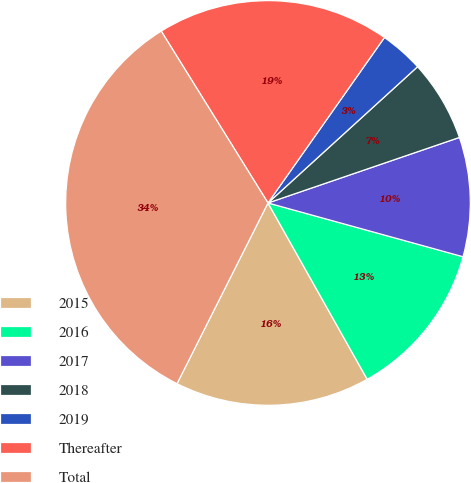<chart> <loc_0><loc_0><loc_500><loc_500><pie_chart><fcel>2015<fcel>2016<fcel>2017<fcel>2018<fcel>2019<fcel>Thereafter<fcel>Total<nl><fcel>15.58%<fcel>12.56%<fcel>9.53%<fcel>6.51%<fcel>3.48%<fcel>18.61%<fcel>33.73%<nl></chart> 